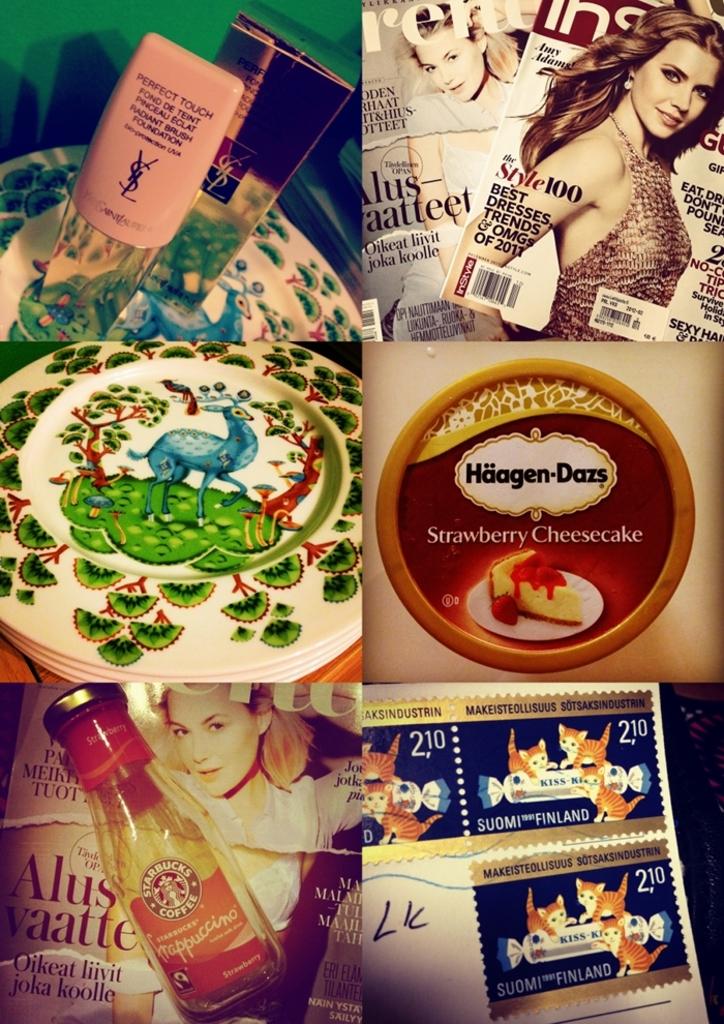What kind of haagen-dazs is on the middle right picture?
Make the answer very short. Strawberry cheesecake. What is the brand of the coffee in lower left picture?
Provide a succinct answer. Starbucks. 